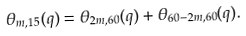Convert formula to latex. <formula><loc_0><loc_0><loc_500><loc_500>\theta _ { m , 1 5 } ( q ) = \theta _ { 2 m , 6 0 } ( q ) + \theta _ { 6 0 - 2 m , 6 0 } ( q ) .</formula> 